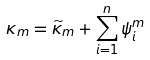<formula> <loc_0><loc_0><loc_500><loc_500>\kappa _ { m } = \widetilde { \kappa } _ { m } + \sum _ { i = 1 } ^ { n } \psi _ { i } ^ { m }</formula> 